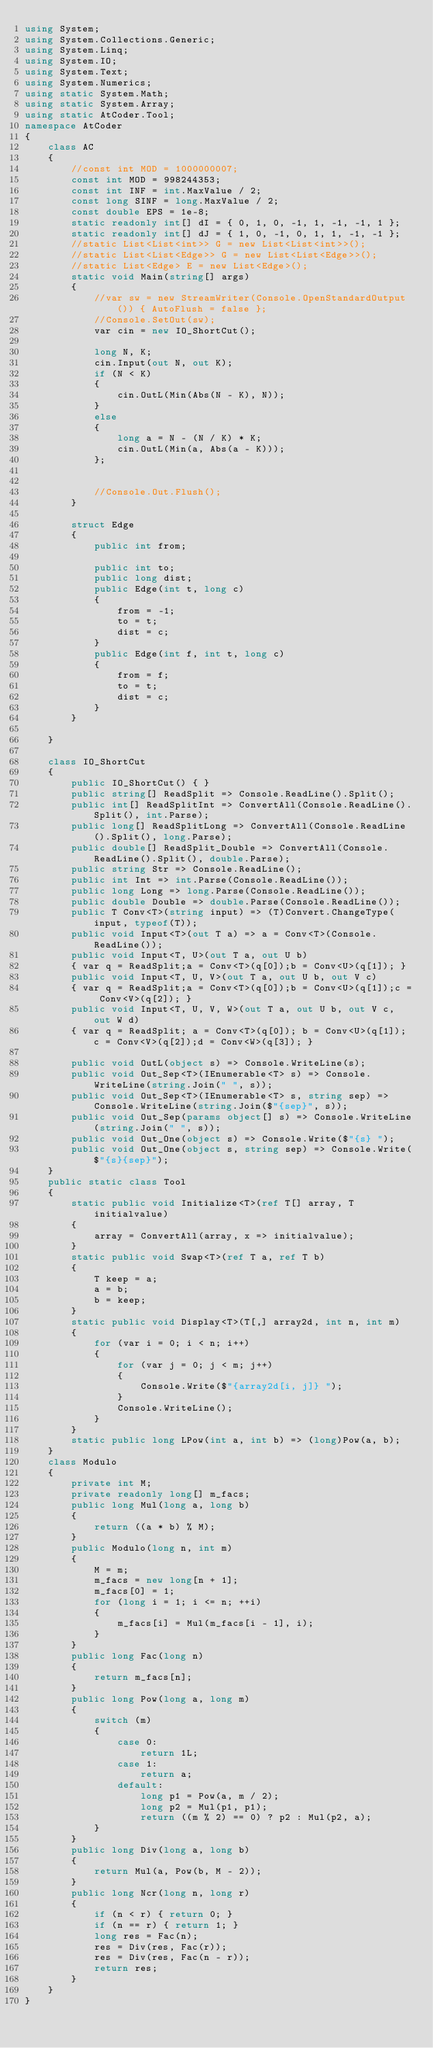<code> <loc_0><loc_0><loc_500><loc_500><_C#_>using System;
using System.Collections.Generic;
using System.Linq;
using System.IO;
using System.Text;
using System.Numerics;
using static System.Math;
using static System.Array;
using static AtCoder.Tool;
namespace AtCoder
{
    class AC
    {
        //const int MOD = 1000000007;
        const int MOD = 998244353;
        const int INF = int.MaxValue / 2;
        const long SINF = long.MaxValue / 2;
        const double EPS = 1e-8;
        static readonly int[] dI = { 0, 1, 0, -1, 1, -1, -1, 1 };
        static readonly int[] dJ = { 1, 0, -1, 0, 1, 1, -1, -1 };
        //static List<List<int>> G = new List<List<int>>();
        //static List<List<Edge>> G = new List<List<Edge>>();
        //static List<Edge> E = new List<Edge>();
        static void Main(string[] args)
        {
            //var sw = new StreamWriter(Console.OpenStandardOutput()) { AutoFlush = false };
            //Console.SetOut(sw);
            var cin = new IO_ShortCut();

            long N, K;
            cin.Input(out N, out K);
            if (N < K)
            {
                cin.OutL(Min(Abs(N - K), N));
            }
            else
            {
                long a = N - (N / K) * K;
                cin.OutL(Min(a, Abs(a - K)));
            };


            //Console.Out.Flush();
        }
        
        struct Edge
        {
            public int from;

            public int to;
            public long dist;
            public Edge(int t, long c)
            {
                from = -1;
                to = t;
                dist = c;
            }
            public Edge(int f, int t, long c)
            {
                from = f;
                to = t;
                dist = c;
            }
        }
        
    }
    
    class IO_ShortCut
    {
        public IO_ShortCut() { }
        public string[] ReadSplit => Console.ReadLine().Split();
        public int[] ReadSplitInt => ConvertAll(Console.ReadLine().Split(), int.Parse);
        public long[] ReadSplitLong => ConvertAll(Console.ReadLine().Split(), long.Parse);
        public double[] ReadSplit_Double => ConvertAll(Console.ReadLine().Split(), double.Parse);
        public string Str => Console.ReadLine();
        public int Int => int.Parse(Console.ReadLine());
        public long Long => long.Parse(Console.ReadLine());
        public double Double => double.Parse(Console.ReadLine());
        public T Conv<T>(string input) => (T)Convert.ChangeType(input, typeof(T));
        public void Input<T>(out T a) => a = Conv<T>(Console.ReadLine());
        public void Input<T, U>(out T a, out U b)
        { var q = ReadSplit;a = Conv<T>(q[0]);b = Conv<U>(q[1]); }
        public void Input<T, U, V>(out T a, out U b, out V c)
        { var q = ReadSplit;a = Conv<T>(q[0]);b = Conv<U>(q[1]);c = Conv<V>(q[2]); }
        public void Input<T, U, V, W>(out T a, out U b, out V c, out W d)
        { var q = ReadSplit; a = Conv<T>(q[0]); b = Conv<U>(q[1]); c = Conv<V>(q[2]);d = Conv<W>(q[3]); }

        public void OutL(object s) => Console.WriteLine(s);
        public void Out_Sep<T>(IEnumerable<T> s) => Console.WriteLine(string.Join(" ", s));
        public void Out_Sep<T>(IEnumerable<T> s, string sep) => Console.WriteLine(string.Join($"{sep}", s));
        public void Out_Sep(params object[] s) => Console.WriteLine(string.Join(" ", s));
        public void Out_One(object s) => Console.Write($"{s} ");
        public void Out_One(object s, string sep) => Console.Write($"{s}{sep}");
    }
    public static class Tool
    {
        static public void Initialize<T>(ref T[] array, T initialvalue)
        {
            array = ConvertAll(array, x => initialvalue);
        }
        static public void Swap<T>(ref T a, ref T b)
        {
            T keep = a;
            a = b;
            b = keep;
        }
        static public void Display<T>(T[,] array2d, int n, int m)
        {
            for (var i = 0; i < n; i++)
            {
                for (var j = 0; j < m; j++)
                {
                    Console.Write($"{array2d[i, j]} ");
                }
                Console.WriteLine();
            }
        }
        static public long LPow(int a, int b) => (long)Pow(a, b);
    }
    class Modulo
    {
        private int M;
        private readonly long[] m_facs;
        public long Mul(long a, long b)
        {
            return ((a * b) % M);
        }
        public Modulo(long n, int m)
        {
            M = m;
            m_facs = new long[n + 1];
            m_facs[0] = 1;
            for (long i = 1; i <= n; ++i)
            {
                m_facs[i] = Mul(m_facs[i - 1], i);
            }
        }
        public long Fac(long n)
        {
            return m_facs[n];
        }
        public long Pow(long a, long m)
        {
            switch (m)
            {
                case 0:
                    return 1L;
                case 1:
                    return a;
                default:
                    long p1 = Pow(a, m / 2);
                    long p2 = Mul(p1, p1);
                    return ((m % 2) == 0) ? p2 : Mul(p2, a);
            }
        }
        public long Div(long a, long b)
        {
            return Mul(a, Pow(b, M - 2));
        }
        public long Ncr(long n, long r)
        {
            if (n < r) { return 0; }
            if (n == r) { return 1; }
            long res = Fac(n);
            res = Div(res, Fac(r));
            res = Div(res, Fac(n - r));
            return res;
        }
    }
}
</code> 